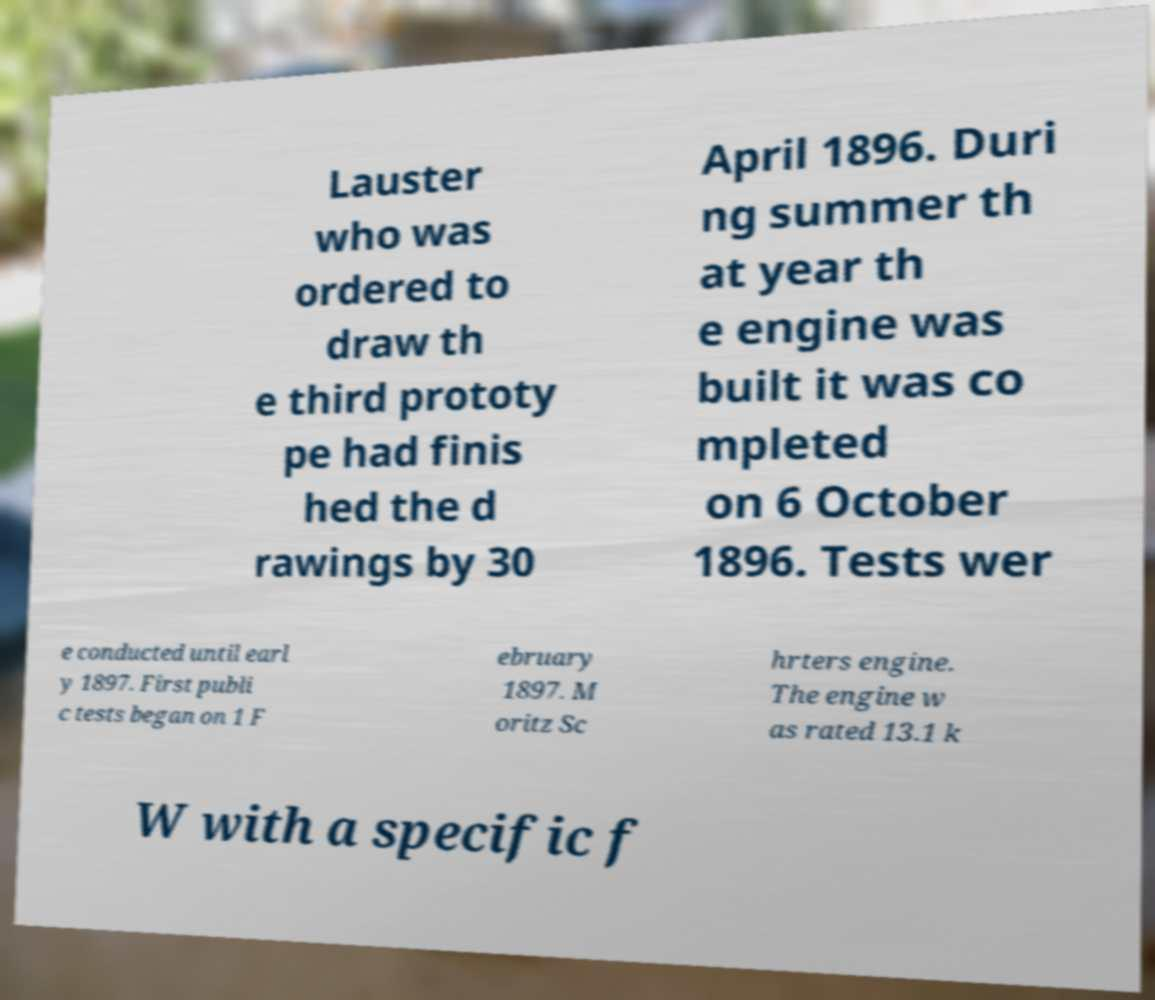There's text embedded in this image that I need extracted. Can you transcribe it verbatim? Lauster who was ordered to draw th e third prototy pe had finis hed the d rawings by 30 April 1896. Duri ng summer th at year th e engine was built it was co mpleted on 6 October 1896. Tests wer e conducted until earl y 1897. First publi c tests began on 1 F ebruary 1897. M oritz Sc hrters engine. The engine w as rated 13.1 k W with a specific f 